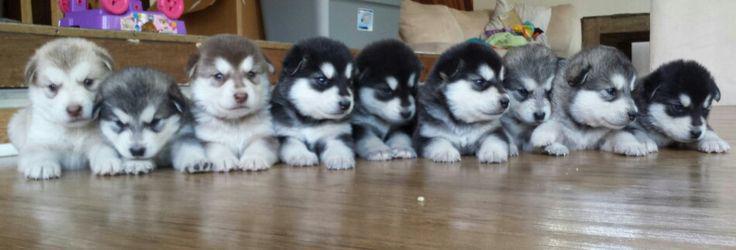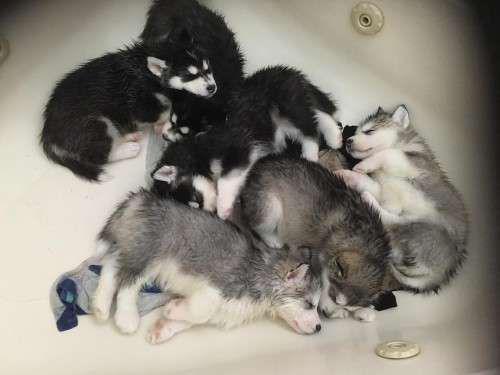The first image is the image on the left, the second image is the image on the right. Analyze the images presented: Is the assertion "There are at most 2 puppies in at least one of the images." valid? Answer yes or no. No. 